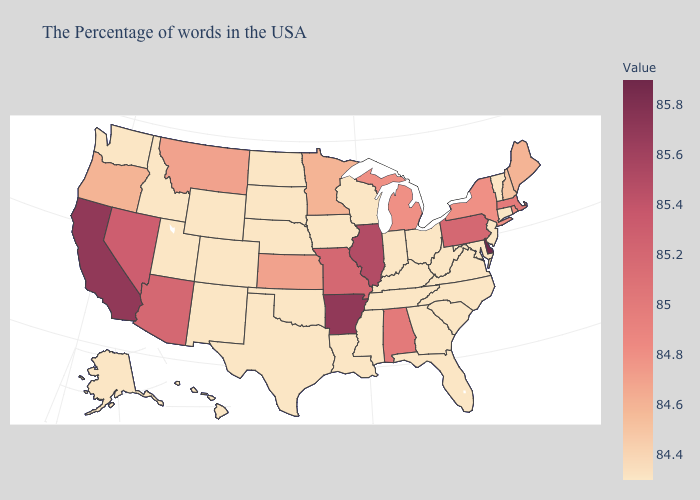Does Delaware have the highest value in the South?
Be succinct. Yes. Which states have the lowest value in the USA?
Short answer required. Vermont, Connecticut, New Jersey, Maryland, Virginia, North Carolina, South Carolina, West Virginia, Ohio, Florida, Georgia, Kentucky, Indiana, Tennessee, Wisconsin, Mississippi, Louisiana, Iowa, Nebraska, Oklahoma, Texas, South Dakota, North Dakota, Wyoming, Colorado, New Mexico, Utah, Idaho, Washington, Alaska, Hawaii. Is the legend a continuous bar?
Concise answer only. Yes. Among the states that border Idaho , which have the highest value?
Concise answer only. Nevada. Does Oregon have the highest value in the USA?
Write a very short answer. No. 